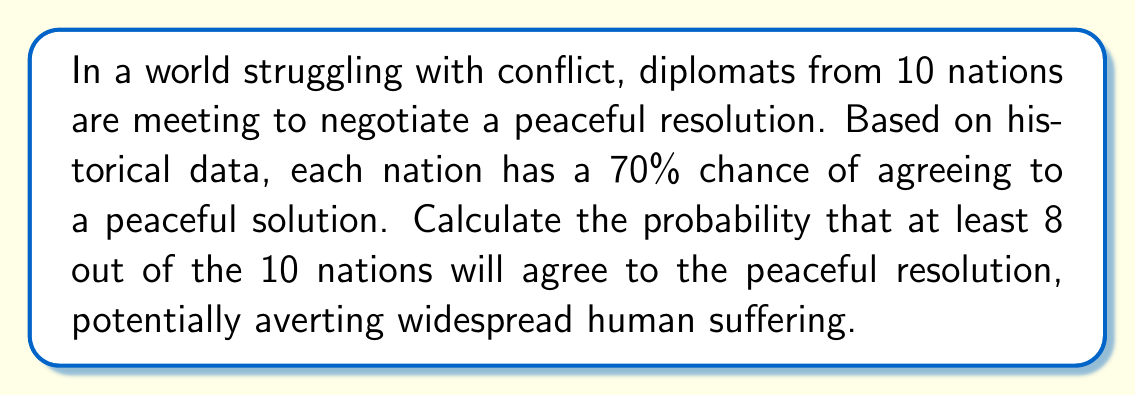Teach me how to tackle this problem. To solve this problem, we'll use the binomial probability distribution. Let's break it down step-by-step:

1) Define our variables:
   $n = 10$ (total number of nations)
   $p = 0.70$ (probability of a nation agreeing to peace)
   $q = 1 - p = 0.30$ (probability of a nation not agreeing)

2) We need to find the probability of 8, 9, or 10 nations agreeing. Let's call this event A.

3) $P(A) = P(X = 8) + P(X = 9) + P(X = 10)$, where X is the number of nations agreeing.

4) The binomial probability formula is:

   $P(X = k) = \binom{n}{k} p^k q^{n-k}$

5) Let's calculate each probability:

   $P(X = 8) = \binom{10}{8} (0.70)^8 (0.30)^2$
              $= 45 \cdot 0.5764801 \cdot 0.09$
              $= 2.33374441$

   $P(X = 9) = \binom{10}{9} (0.70)^9 (0.30)^1$
              $= 10 \cdot 0.40353607 \cdot 0.30$
              $= 1.21060821$

   $P(X = 10) = \binom{10}{10} (0.70)^{10} (0.30)^0$
               $= 1 \cdot 0.28247524 \cdot 1$
               $= 0.28247524$

6) Sum these probabilities:

   $P(A) = 2.33374441 + 1.21060821 + 0.28247524 = 0.82682786$

Therefore, the probability of at least 8 out of 10 nations agreeing to the peaceful resolution is approximately 0.8268 or 82.68%.
Answer: The probability that at least 8 out of the 10 nations will agree to the peaceful resolution is approximately $0.8268$ or $82.68\%$. 